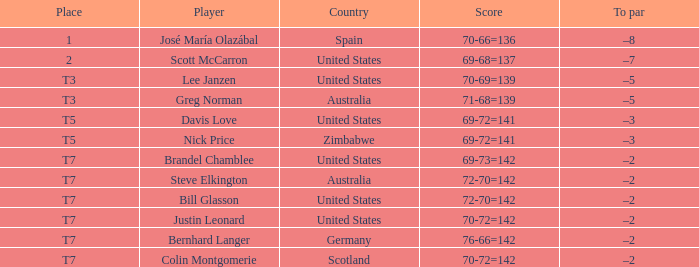Name the Player who has a Country of united states, and a To par of –5? Lee Janzen. 